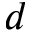Convert formula to latex. <formula><loc_0><loc_0><loc_500><loc_500>d</formula> 